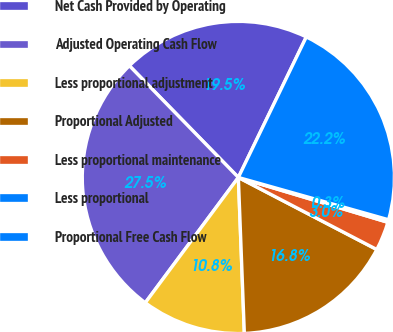Convert chart. <chart><loc_0><loc_0><loc_500><loc_500><pie_chart><fcel>Net Cash Provided by Operating<fcel>Adjusted Operating Cash Flow<fcel>Less proportional adjustment<fcel>Proportional Adjusted<fcel>Less proportional maintenance<fcel>Less proportional<fcel>Proportional Free Cash Flow<nl><fcel>19.47%<fcel>27.53%<fcel>10.78%<fcel>16.75%<fcel>3.0%<fcel>0.27%<fcel>22.2%<nl></chart> 